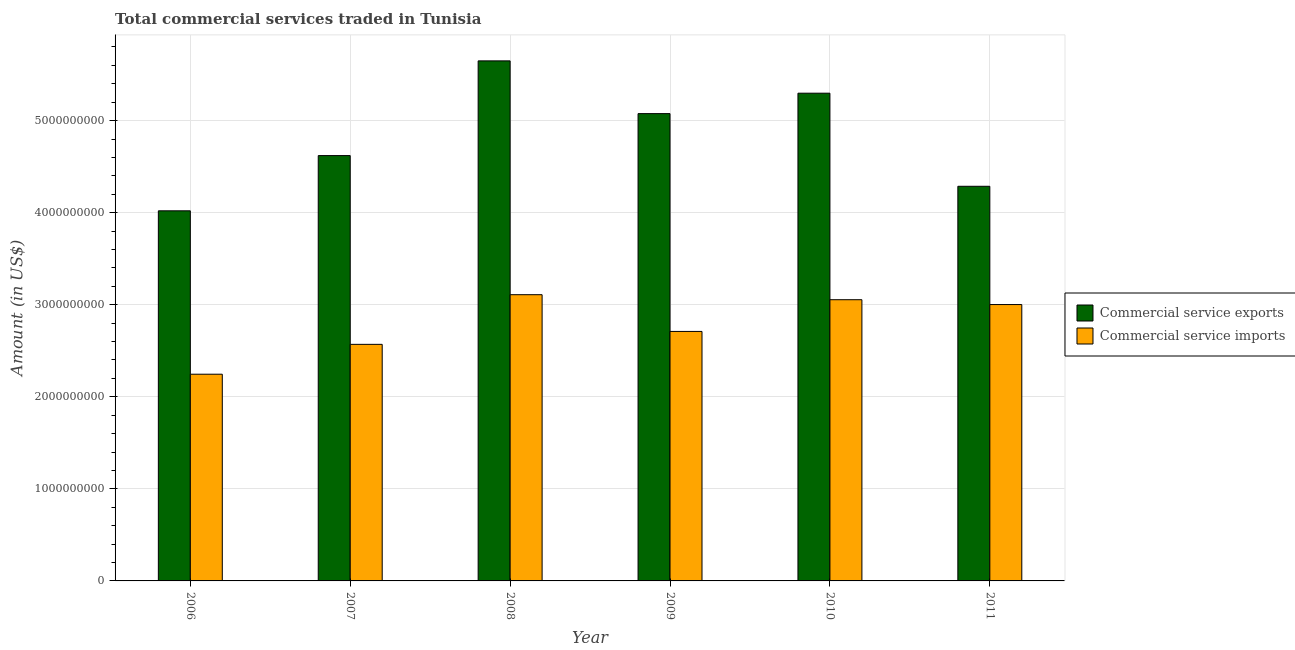How many different coloured bars are there?
Your answer should be very brief. 2. Are the number of bars on each tick of the X-axis equal?
Ensure brevity in your answer.  Yes. How many bars are there on the 6th tick from the right?
Give a very brief answer. 2. What is the amount of commercial service imports in 2007?
Provide a succinct answer. 2.57e+09. Across all years, what is the maximum amount of commercial service imports?
Make the answer very short. 3.11e+09. Across all years, what is the minimum amount of commercial service exports?
Provide a short and direct response. 4.02e+09. What is the total amount of commercial service imports in the graph?
Offer a terse response. 1.67e+1. What is the difference between the amount of commercial service imports in 2010 and that in 2011?
Make the answer very short. 5.25e+07. What is the difference between the amount of commercial service exports in 2006 and the amount of commercial service imports in 2008?
Your response must be concise. -1.63e+09. What is the average amount of commercial service exports per year?
Your answer should be very brief. 4.82e+09. In the year 2008, what is the difference between the amount of commercial service exports and amount of commercial service imports?
Offer a terse response. 0. In how many years, is the amount of commercial service imports greater than 3000000000 US$?
Give a very brief answer. 3. What is the ratio of the amount of commercial service imports in 2007 to that in 2008?
Your answer should be compact. 0.83. Is the amount of commercial service exports in 2006 less than that in 2011?
Your answer should be compact. Yes. What is the difference between the highest and the second highest amount of commercial service imports?
Your answer should be very brief. 5.46e+07. What is the difference between the highest and the lowest amount of commercial service exports?
Provide a short and direct response. 1.63e+09. In how many years, is the amount of commercial service exports greater than the average amount of commercial service exports taken over all years?
Your answer should be compact. 3. What does the 1st bar from the left in 2009 represents?
Provide a succinct answer. Commercial service exports. What does the 1st bar from the right in 2008 represents?
Keep it short and to the point. Commercial service imports. Are all the bars in the graph horizontal?
Your answer should be very brief. No. How many years are there in the graph?
Make the answer very short. 6. Where does the legend appear in the graph?
Your answer should be compact. Center right. How many legend labels are there?
Keep it short and to the point. 2. What is the title of the graph?
Your response must be concise. Total commercial services traded in Tunisia. What is the label or title of the Y-axis?
Your response must be concise. Amount (in US$). What is the Amount (in US$) in Commercial service exports in 2006?
Ensure brevity in your answer.  4.02e+09. What is the Amount (in US$) of Commercial service imports in 2006?
Provide a succinct answer. 2.25e+09. What is the Amount (in US$) of Commercial service exports in 2007?
Offer a terse response. 4.62e+09. What is the Amount (in US$) in Commercial service imports in 2007?
Make the answer very short. 2.57e+09. What is the Amount (in US$) in Commercial service exports in 2008?
Provide a short and direct response. 5.65e+09. What is the Amount (in US$) in Commercial service imports in 2008?
Offer a very short reply. 3.11e+09. What is the Amount (in US$) of Commercial service exports in 2009?
Offer a very short reply. 5.08e+09. What is the Amount (in US$) in Commercial service imports in 2009?
Your answer should be very brief. 2.71e+09. What is the Amount (in US$) in Commercial service exports in 2010?
Give a very brief answer. 5.30e+09. What is the Amount (in US$) in Commercial service imports in 2010?
Your answer should be very brief. 3.05e+09. What is the Amount (in US$) of Commercial service exports in 2011?
Offer a very short reply. 4.29e+09. What is the Amount (in US$) in Commercial service imports in 2011?
Your response must be concise. 3.00e+09. Across all years, what is the maximum Amount (in US$) in Commercial service exports?
Provide a short and direct response. 5.65e+09. Across all years, what is the maximum Amount (in US$) of Commercial service imports?
Your answer should be compact. 3.11e+09. Across all years, what is the minimum Amount (in US$) in Commercial service exports?
Offer a terse response. 4.02e+09. Across all years, what is the minimum Amount (in US$) in Commercial service imports?
Ensure brevity in your answer.  2.25e+09. What is the total Amount (in US$) of Commercial service exports in the graph?
Provide a short and direct response. 2.89e+1. What is the total Amount (in US$) in Commercial service imports in the graph?
Your answer should be compact. 1.67e+1. What is the difference between the Amount (in US$) in Commercial service exports in 2006 and that in 2007?
Your answer should be very brief. -6.00e+08. What is the difference between the Amount (in US$) in Commercial service imports in 2006 and that in 2007?
Offer a terse response. -3.24e+08. What is the difference between the Amount (in US$) in Commercial service exports in 2006 and that in 2008?
Offer a very short reply. -1.63e+09. What is the difference between the Amount (in US$) of Commercial service imports in 2006 and that in 2008?
Ensure brevity in your answer.  -8.64e+08. What is the difference between the Amount (in US$) in Commercial service exports in 2006 and that in 2009?
Make the answer very short. -1.06e+09. What is the difference between the Amount (in US$) of Commercial service imports in 2006 and that in 2009?
Ensure brevity in your answer.  -4.65e+08. What is the difference between the Amount (in US$) in Commercial service exports in 2006 and that in 2010?
Make the answer very short. -1.28e+09. What is the difference between the Amount (in US$) of Commercial service imports in 2006 and that in 2010?
Make the answer very short. -8.09e+08. What is the difference between the Amount (in US$) in Commercial service exports in 2006 and that in 2011?
Offer a very short reply. -2.66e+08. What is the difference between the Amount (in US$) of Commercial service imports in 2006 and that in 2011?
Your answer should be very brief. -7.57e+08. What is the difference between the Amount (in US$) in Commercial service exports in 2007 and that in 2008?
Your response must be concise. -1.03e+09. What is the difference between the Amount (in US$) in Commercial service imports in 2007 and that in 2008?
Your answer should be very brief. -5.40e+08. What is the difference between the Amount (in US$) of Commercial service exports in 2007 and that in 2009?
Ensure brevity in your answer.  -4.56e+08. What is the difference between the Amount (in US$) in Commercial service imports in 2007 and that in 2009?
Give a very brief answer. -1.40e+08. What is the difference between the Amount (in US$) of Commercial service exports in 2007 and that in 2010?
Offer a very short reply. -6.78e+08. What is the difference between the Amount (in US$) in Commercial service imports in 2007 and that in 2010?
Provide a succinct answer. -4.85e+08. What is the difference between the Amount (in US$) of Commercial service exports in 2007 and that in 2011?
Give a very brief answer. 3.33e+08. What is the difference between the Amount (in US$) in Commercial service imports in 2007 and that in 2011?
Make the answer very short. -4.32e+08. What is the difference between the Amount (in US$) of Commercial service exports in 2008 and that in 2009?
Offer a terse response. 5.73e+08. What is the difference between the Amount (in US$) in Commercial service imports in 2008 and that in 2009?
Provide a short and direct response. 3.99e+08. What is the difference between the Amount (in US$) in Commercial service exports in 2008 and that in 2010?
Give a very brief answer. 3.51e+08. What is the difference between the Amount (in US$) of Commercial service imports in 2008 and that in 2010?
Ensure brevity in your answer.  5.46e+07. What is the difference between the Amount (in US$) in Commercial service exports in 2008 and that in 2011?
Provide a short and direct response. 1.36e+09. What is the difference between the Amount (in US$) in Commercial service imports in 2008 and that in 2011?
Ensure brevity in your answer.  1.07e+08. What is the difference between the Amount (in US$) in Commercial service exports in 2009 and that in 2010?
Give a very brief answer. -2.22e+08. What is the difference between the Amount (in US$) of Commercial service imports in 2009 and that in 2010?
Your answer should be very brief. -3.45e+08. What is the difference between the Amount (in US$) in Commercial service exports in 2009 and that in 2011?
Offer a very short reply. 7.89e+08. What is the difference between the Amount (in US$) in Commercial service imports in 2009 and that in 2011?
Provide a short and direct response. -2.92e+08. What is the difference between the Amount (in US$) in Commercial service exports in 2010 and that in 2011?
Your response must be concise. 1.01e+09. What is the difference between the Amount (in US$) in Commercial service imports in 2010 and that in 2011?
Your answer should be very brief. 5.25e+07. What is the difference between the Amount (in US$) in Commercial service exports in 2006 and the Amount (in US$) in Commercial service imports in 2007?
Give a very brief answer. 1.45e+09. What is the difference between the Amount (in US$) in Commercial service exports in 2006 and the Amount (in US$) in Commercial service imports in 2008?
Provide a succinct answer. 9.11e+08. What is the difference between the Amount (in US$) of Commercial service exports in 2006 and the Amount (in US$) of Commercial service imports in 2009?
Keep it short and to the point. 1.31e+09. What is the difference between the Amount (in US$) of Commercial service exports in 2006 and the Amount (in US$) of Commercial service imports in 2010?
Ensure brevity in your answer.  9.66e+08. What is the difference between the Amount (in US$) in Commercial service exports in 2006 and the Amount (in US$) in Commercial service imports in 2011?
Make the answer very short. 1.02e+09. What is the difference between the Amount (in US$) in Commercial service exports in 2007 and the Amount (in US$) in Commercial service imports in 2008?
Give a very brief answer. 1.51e+09. What is the difference between the Amount (in US$) of Commercial service exports in 2007 and the Amount (in US$) of Commercial service imports in 2009?
Provide a succinct answer. 1.91e+09. What is the difference between the Amount (in US$) of Commercial service exports in 2007 and the Amount (in US$) of Commercial service imports in 2010?
Keep it short and to the point. 1.57e+09. What is the difference between the Amount (in US$) in Commercial service exports in 2007 and the Amount (in US$) in Commercial service imports in 2011?
Provide a short and direct response. 1.62e+09. What is the difference between the Amount (in US$) in Commercial service exports in 2008 and the Amount (in US$) in Commercial service imports in 2009?
Provide a short and direct response. 2.94e+09. What is the difference between the Amount (in US$) in Commercial service exports in 2008 and the Amount (in US$) in Commercial service imports in 2010?
Offer a very short reply. 2.59e+09. What is the difference between the Amount (in US$) of Commercial service exports in 2008 and the Amount (in US$) of Commercial service imports in 2011?
Make the answer very short. 2.65e+09. What is the difference between the Amount (in US$) of Commercial service exports in 2009 and the Amount (in US$) of Commercial service imports in 2010?
Your response must be concise. 2.02e+09. What is the difference between the Amount (in US$) in Commercial service exports in 2009 and the Amount (in US$) in Commercial service imports in 2011?
Make the answer very short. 2.07e+09. What is the difference between the Amount (in US$) of Commercial service exports in 2010 and the Amount (in US$) of Commercial service imports in 2011?
Provide a succinct answer. 2.30e+09. What is the average Amount (in US$) of Commercial service exports per year?
Keep it short and to the point. 4.82e+09. What is the average Amount (in US$) of Commercial service imports per year?
Make the answer very short. 2.78e+09. In the year 2006, what is the difference between the Amount (in US$) in Commercial service exports and Amount (in US$) in Commercial service imports?
Keep it short and to the point. 1.77e+09. In the year 2007, what is the difference between the Amount (in US$) of Commercial service exports and Amount (in US$) of Commercial service imports?
Your answer should be compact. 2.05e+09. In the year 2008, what is the difference between the Amount (in US$) of Commercial service exports and Amount (in US$) of Commercial service imports?
Offer a very short reply. 2.54e+09. In the year 2009, what is the difference between the Amount (in US$) in Commercial service exports and Amount (in US$) in Commercial service imports?
Give a very brief answer. 2.37e+09. In the year 2010, what is the difference between the Amount (in US$) of Commercial service exports and Amount (in US$) of Commercial service imports?
Your answer should be very brief. 2.24e+09. In the year 2011, what is the difference between the Amount (in US$) in Commercial service exports and Amount (in US$) in Commercial service imports?
Provide a short and direct response. 1.28e+09. What is the ratio of the Amount (in US$) of Commercial service exports in 2006 to that in 2007?
Your answer should be very brief. 0.87. What is the ratio of the Amount (in US$) of Commercial service imports in 2006 to that in 2007?
Provide a short and direct response. 0.87. What is the ratio of the Amount (in US$) of Commercial service exports in 2006 to that in 2008?
Offer a terse response. 0.71. What is the ratio of the Amount (in US$) in Commercial service imports in 2006 to that in 2008?
Make the answer very short. 0.72. What is the ratio of the Amount (in US$) in Commercial service exports in 2006 to that in 2009?
Provide a succinct answer. 0.79. What is the ratio of the Amount (in US$) in Commercial service imports in 2006 to that in 2009?
Your response must be concise. 0.83. What is the ratio of the Amount (in US$) of Commercial service exports in 2006 to that in 2010?
Ensure brevity in your answer.  0.76. What is the ratio of the Amount (in US$) of Commercial service imports in 2006 to that in 2010?
Ensure brevity in your answer.  0.74. What is the ratio of the Amount (in US$) of Commercial service exports in 2006 to that in 2011?
Ensure brevity in your answer.  0.94. What is the ratio of the Amount (in US$) of Commercial service imports in 2006 to that in 2011?
Offer a very short reply. 0.75. What is the ratio of the Amount (in US$) of Commercial service exports in 2007 to that in 2008?
Offer a very short reply. 0.82. What is the ratio of the Amount (in US$) of Commercial service imports in 2007 to that in 2008?
Your answer should be very brief. 0.83. What is the ratio of the Amount (in US$) in Commercial service exports in 2007 to that in 2009?
Give a very brief answer. 0.91. What is the ratio of the Amount (in US$) of Commercial service imports in 2007 to that in 2009?
Provide a short and direct response. 0.95. What is the ratio of the Amount (in US$) in Commercial service exports in 2007 to that in 2010?
Offer a very short reply. 0.87. What is the ratio of the Amount (in US$) in Commercial service imports in 2007 to that in 2010?
Provide a short and direct response. 0.84. What is the ratio of the Amount (in US$) of Commercial service exports in 2007 to that in 2011?
Keep it short and to the point. 1.08. What is the ratio of the Amount (in US$) of Commercial service imports in 2007 to that in 2011?
Keep it short and to the point. 0.86. What is the ratio of the Amount (in US$) of Commercial service exports in 2008 to that in 2009?
Make the answer very short. 1.11. What is the ratio of the Amount (in US$) of Commercial service imports in 2008 to that in 2009?
Offer a terse response. 1.15. What is the ratio of the Amount (in US$) in Commercial service exports in 2008 to that in 2010?
Offer a terse response. 1.07. What is the ratio of the Amount (in US$) in Commercial service imports in 2008 to that in 2010?
Give a very brief answer. 1.02. What is the ratio of the Amount (in US$) in Commercial service exports in 2008 to that in 2011?
Provide a succinct answer. 1.32. What is the ratio of the Amount (in US$) of Commercial service imports in 2008 to that in 2011?
Offer a very short reply. 1.04. What is the ratio of the Amount (in US$) in Commercial service exports in 2009 to that in 2010?
Keep it short and to the point. 0.96. What is the ratio of the Amount (in US$) in Commercial service imports in 2009 to that in 2010?
Give a very brief answer. 0.89. What is the ratio of the Amount (in US$) in Commercial service exports in 2009 to that in 2011?
Offer a terse response. 1.18. What is the ratio of the Amount (in US$) in Commercial service imports in 2009 to that in 2011?
Keep it short and to the point. 0.9. What is the ratio of the Amount (in US$) in Commercial service exports in 2010 to that in 2011?
Keep it short and to the point. 1.24. What is the ratio of the Amount (in US$) of Commercial service imports in 2010 to that in 2011?
Your answer should be very brief. 1.02. What is the difference between the highest and the second highest Amount (in US$) in Commercial service exports?
Keep it short and to the point. 3.51e+08. What is the difference between the highest and the second highest Amount (in US$) in Commercial service imports?
Give a very brief answer. 5.46e+07. What is the difference between the highest and the lowest Amount (in US$) in Commercial service exports?
Offer a terse response. 1.63e+09. What is the difference between the highest and the lowest Amount (in US$) in Commercial service imports?
Offer a terse response. 8.64e+08. 